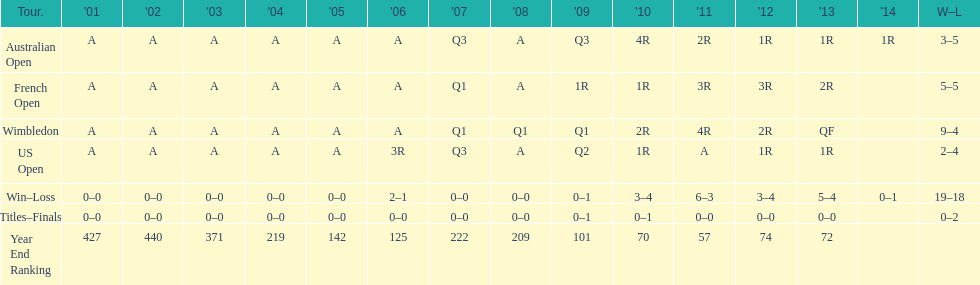Which years was a ranking below 200 achieved? 2005, 2006, 2009, 2010, 2011, 2012, 2013. 